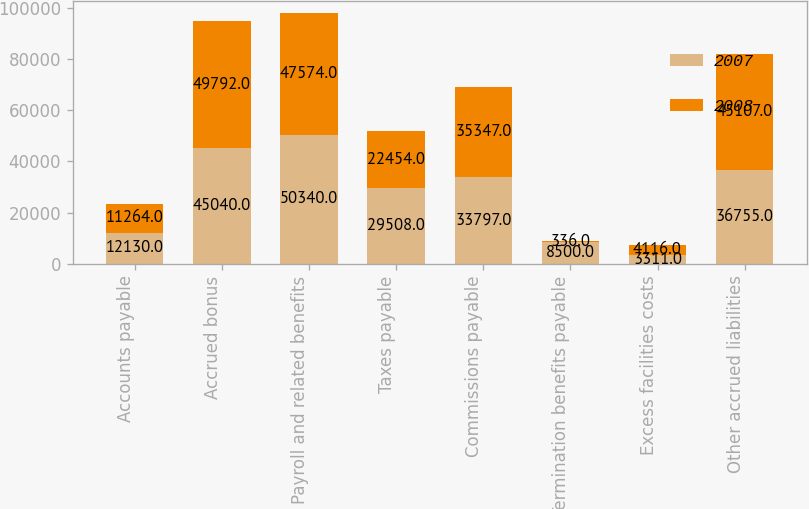<chart> <loc_0><loc_0><loc_500><loc_500><stacked_bar_chart><ecel><fcel>Accounts payable<fcel>Accrued bonus<fcel>Payroll and related benefits<fcel>Taxes payable<fcel>Commissions payable<fcel>Termination benefits payable<fcel>Excess facilities costs<fcel>Other accrued liabilities<nl><fcel>2007<fcel>12130<fcel>45040<fcel>50340<fcel>29508<fcel>33797<fcel>8500<fcel>3311<fcel>36755<nl><fcel>2008<fcel>11264<fcel>49792<fcel>47574<fcel>22454<fcel>35347<fcel>336<fcel>4116<fcel>45107<nl></chart> 